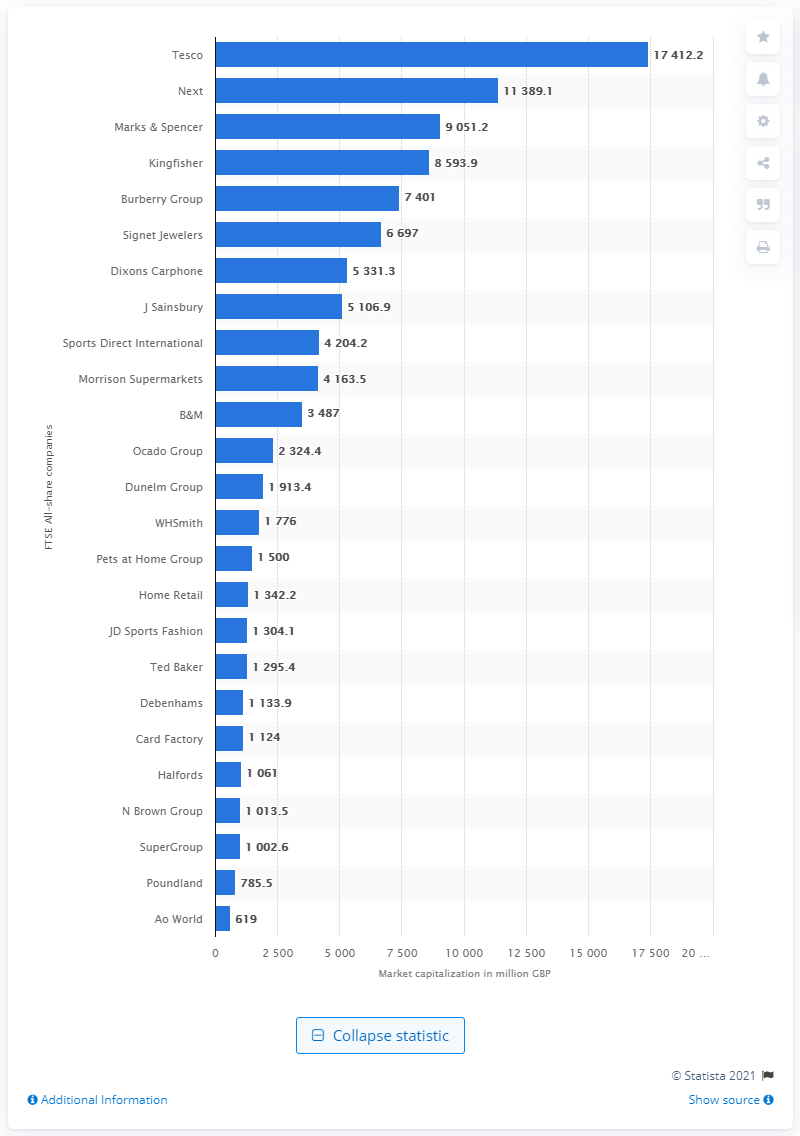Give some essential details in this illustration. As of the given date, Tesco's market capitalization was 17,412.2... 